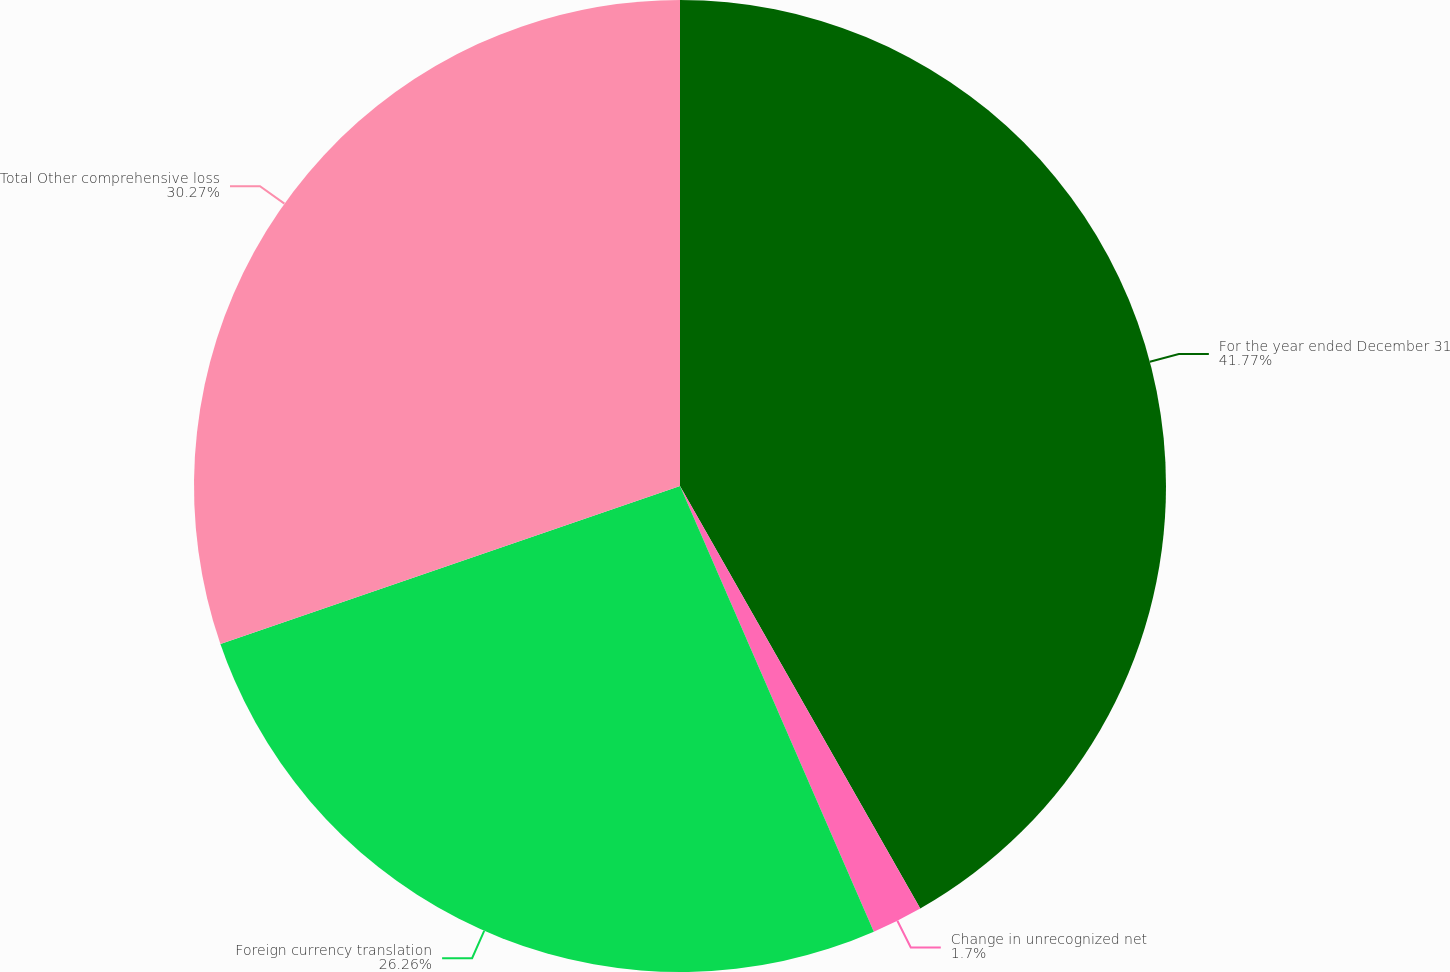<chart> <loc_0><loc_0><loc_500><loc_500><pie_chart><fcel>For the year ended December 31<fcel>Change in unrecognized net<fcel>Foreign currency translation<fcel>Total Other comprehensive loss<nl><fcel>41.77%<fcel>1.7%<fcel>26.26%<fcel>30.27%<nl></chart> 